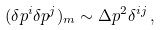<formula> <loc_0><loc_0><loc_500><loc_500>( \delta p ^ { i } \delta p ^ { j } ) _ { m } \sim \Delta p ^ { 2 } \delta ^ { i j } \, { , }</formula> 